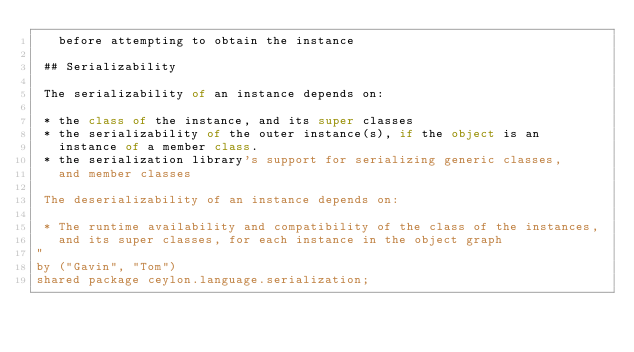<code> <loc_0><loc_0><loc_500><loc_500><_Ceylon_>   before attempting to obtain the instance  
 
 ## Serializability
 
 The serializability of an instance depends on:
 
 * the class of the instance, and its super classes
 * the serializability of the outer instance(s), if the object is an 
   instance of a member class.  
 * the serialization library's support for serializing generic classes, 
   and member classes
   
 The deserializability of an instance depends on:
 
 * The runtime availability and compatibility of the class of the instances, 
   and its super classes, for each instance in the object graph 
"
by ("Gavin", "Tom")
shared package ceylon.language.serialization;
</code> 